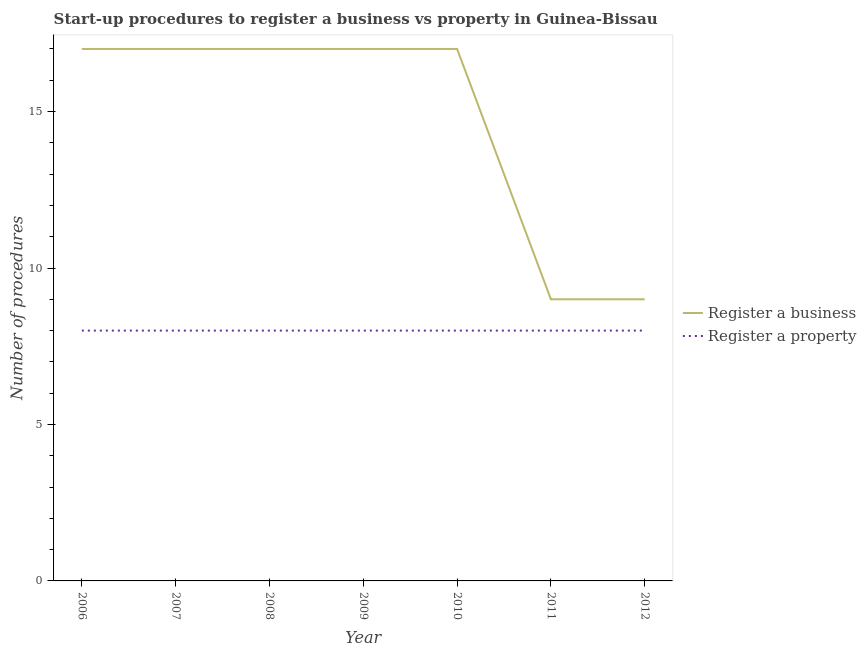How many different coloured lines are there?
Keep it short and to the point. 2. Does the line corresponding to number of procedures to register a business intersect with the line corresponding to number of procedures to register a property?
Provide a short and direct response. No. Is the number of lines equal to the number of legend labels?
Your response must be concise. Yes. What is the number of procedures to register a property in 2011?
Give a very brief answer. 8. Across all years, what is the maximum number of procedures to register a property?
Give a very brief answer. 8. Across all years, what is the minimum number of procedures to register a business?
Your answer should be compact. 9. In which year was the number of procedures to register a business maximum?
Keep it short and to the point. 2006. In which year was the number of procedures to register a business minimum?
Offer a terse response. 2011. What is the total number of procedures to register a business in the graph?
Offer a terse response. 103. What is the difference between the number of procedures to register a property in 2011 and the number of procedures to register a business in 2007?
Provide a short and direct response. -9. What is the average number of procedures to register a business per year?
Keep it short and to the point. 14.71. In the year 2007, what is the difference between the number of procedures to register a property and number of procedures to register a business?
Your answer should be very brief. -9. What is the ratio of the number of procedures to register a property in 2008 to that in 2011?
Your answer should be very brief. 1. Is the number of procedures to register a business in 2011 less than that in 2012?
Offer a terse response. No. Is the difference between the number of procedures to register a business in 2008 and 2012 greater than the difference between the number of procedures to register a property in 2008 and 2012?
Ensure brevity in your answer.  Yes. What is the difference between the highest and the second highest number of procedures to register a business?
Your answer should be very brief. 0. What is the difference between the highest and the lowest number of procedures to register a business?
Your answer should be very brief. 8. In how many years, is the number of procedures to register a property greater than the average number of procedures to register a property taken over all years?
Make the answer very short. 0. Is the sum of the number of procedures to register a business in 2006 and 2011 greater than the maximum number of procedures to register a property across all years?
Your answer should be very brief. Yes. Is the number of procedures to register a business strictly less than the number of procedures to register a property over the years?
Ensure brevity in your answer.  No. What is the difference between two consecutive major ticks on the Y-axis?
Offer a very short reply. 5. Are the values on the major ticks of Y-axis written in scientific E-notation?
Provide a short and direct response. No. Where does the legend appear in the graph?
Provide a succinct answer. Center right. What is the title of the graph?
Offer a terse response. Start-up procedures to register a business vs property in Guinea-Bissau. Does "Primary school" appear as one of the legend labels in the graph?
Provide a short and direct response. No. What is the label or title of the Y-axis?
Keep it short and to the point. Number of procedures. What is the Number of procedures in Register a property in 2006?
Provide a succinct answer. 8. What is the Number of procedures in Register a property in 2009?
Your answer should be very brief. 8. What is the Number of procedures in Register a business in 2010?
Make the answer very short. 17. What is the Number of procedures of Register a property in 2010?
Provide a short and direct response. 8. What is the Number of procedures of Register a business in 2011?
Provide a short and direct response. 9. What is the Number of procedures in Register a property in 2012?
Offer a very short reply. 8. Across all years, what is the minimum Number of procedures of Register a business?
Offer a terse response. 9. What is the total Number of procedures of Register a business in the graph?
Offer a terse response. 103. What is the difference between the Number of procedures of Register a business in 2006 and that in 2007?
Provide a succinct answer. 0. What is the difference between the Number of procedures of Register a property in 2006 and that in 2007?
Give a very brief answer. 0. What is the difference between the Number of procedures of Register a property in 2006 and that in 2009?
Give a very brief answer. 0. What is the difference between the Number of procedures of Register a business in 2006 and that in 2010?
Provide a succinct answer. 0. What is the difference between the Number of procedures of Register a business in 2006 and that in 2011?
Your answer should be very brief. 8. What is the difference between the Number of procedures of Register a property in 2006 and that in 2012?
Your response must be concise. 0. What is the difference between the Number of procedures of Register a business in 2007 and that in 2008?
Provide a succinct answer. 0. What is the difference between the Number of procedures in Register a property in 2007 and that in 2008?
Offer a terse response. 0. What is the difference between the Number of procedures in Register a business in 2007 and that in 2010?
Ensure brevity in your answer.  0. What is the difference between the Number of procedures of Register a business in 2007 and that in 2012?
Your answer should be compact. 8. What is the difference between the Number of procedures in Register a property in 2007 and that in 2012?
Your answer should be very brief. 0. What is the difference between the Number of procedures in Register a property in 2008 and that in 2009?
Your answer should be compact. 0. What is the difference between the Number of procedures of Register a business in 2008 and that in 2010?
Give a very brief answer. 0. What is the difference between the Number of procedures in Register a property in 2008 and that in 2011?
Provide a short and direct response. 0. What is the difference between the Number of procedures in Register a business in 2008 and that in 2012?
Ensure brevity in your answer.  8. What is the difference between the Number of procedures of Register a property in 2008 and that in 2012?
Your response must be concise. 0. What is the difference between the Number of procedures of Register a business in 2009 and that in 2010?
Keep it short and to the point. 0. What is the difference between the Number of procedures of Register a business in 2009 and that in 2011?
Keep it short and to the point. 8. What is the difference between the Number of procedures in Register a business in 2010 and that in 2012?
Your answer should be compact. 8. What is the difference between the Number of procedures of Register a business in 2011 and that in 2012?
Offer a terse response. 0. What is the difference between the Number of procedures in Register a business in 2006 and the Number of procedures in Register a property in 2007?
Ensure brevity in your answer.  9. What is the difference between the Number of procedures of Register a business in 2006 and the Number of procedures of Register a property in 2008?
Ensure brevity in your answer.  9. What is the difference between the Number of procedures in Register a business in 2006 and the Number of procedures in Register a property in 2009?
Your answer should be compact. 9. What is the difference between the Number of procedures of Register a business in 2007 and the Number of procedures of Register a property in 2008?
Ensure brevity in your answer.  9. What is the difference between the Number of procedures in Register a business in 2008 and the Number of procedures in Register a property in 2009?
Keep it short and to the point. 9. What is the difference between the Number of procedures of Register a business in 2008 and the Number of procedures of Register a property in 2010?
Keep it short and to the point. 9. What is the difference between the Number of procedures in Register a business in 2008 and the Number of procedures in Register a property in 2012?
Provide a succinct answer. 9. What is the difference between the Number of procedures in Register a business in 2009 and the Number of procedures in Register a property in 2010?
Give a very brief answer. 9. What is the difference between the Number of procedures of Register a business in 2010 and the Number of procedures of Register a property in 2011?
Your answer should be very brief. 9. What is the difference between the Number of procedures in Register a business in 2011 and the Number of procedures in Register a property in 2012?
Offer a terse response. 1. What is the average Number of procedures in Register a business per year?
Your answer should be compact. 14.71. What is the average Number of procedures in Register a property per year?
Make the answer very short. 8. In the year 2007, what is the difference between the Number of procedures in Register a business and Number of procedures in Register a property?
Keep it short and to the point. 9. In the year 2008, what is the difference between the Number of procedures of Register a business and Number of procedures of Register a property?
Your response must be concise. 9. In the year 2009, what is the difference between the Number of procedures of Register a business and Number of procedures of Register a property?
Offer a very short reply. 9. In the year 2011, what is the difference between the Number of procedures in Register a business and Number of procedures in Register a property?
Offer a very short reply. 1. In the year 2012, what is the difference between the Number of procedures in Register a business and Number of procedures in Register a property?
Ensure brevity in your answer.  1. What is the ratio of the Number of procedures in Register a business in 2006 to that in 2007?
Your answer should be very brief. 1. What is the ratio of the Number of procedures of Register a property in 2006 to that in 2007?
Offer a terse response. 1. What is the ratio of the Number of procedures in Register a business in 2006 to that in 2008?
Make the answer very short. 1. What is the ratio of the Number of procedures of Register a property in 2006 to that in 2008?
Your answer should be very brief. 1. What is the ratio of the Number of procedures of Register a business in 2006 to that in 2009?
Keep it short and to the point. 1. What is the ratio of the Number of procedures in Register a property in 2006 to that in 2010?
Provide a succinct answer. 1. What is the ratio of the Number of procedures of Register a business in 2006 to that in 2011?
Your answer should be compact. 1.89. What is the ratio of the Number of procedures of Register a property in 2006 to that in 2011?
Your answer should be very brief. 1. What is the ratio of the Number of procedures of Register a business in 2006 to that in 2012?
Make the answer very short. 1.89. What is the ratio of the Number of procedures of Register a property in 2007 to that in 2008?
Make the answer very short. 1. What is the ratio of the Number of procedures of Register a property in 2007 to that in 2009?
Your answer should be very brief. 1. What is the ratio of the Number of procedures of Register a property in 2007 to that in 2010?
Offer a very short reply. 1. What is the ratio of the Number of procedures in Register a business in 2007 to that in 2011?
Your answer should be compact. 1.89. What is the ratio of the Number of procedures in Register a property in 2007 to that in 2011?
Offer a very short reply. 1. What is the ratio of the Number of procedures in Register a business in 2007 to that in 2012?
Your response must be concise. 1.89. What is the ratio of the Number of procedures of Register a business in 2008 to that in 2009?
Provide a short and direct response. 1. What is the ratio of the Number of procedures in Register a business in 2008 to that in 2010?
Your response must be concise. 1. What is the ratio of the Number of procedures in Register a business in 2008 to that in 2011?
Your response must be concise. 1.89. What is the ratio of the Number of procedures of Register a business in 2008 to that in 2012?
Offer a very short reply. 1.89. What is the ratio of the Number of procedures of Register a business in 2009 to that in 2010?
Keep it short and to the point. 1. What is the ratio of the Number of procedures of Register a property in 2009 to that in 2010?
Offer a very short reply. 1. What is the ratio of the Number of procedures of Register a business in 2009 to that in 2011?
Ensure brevity in your answer.  1.89. What is the ratio of the Number of procedures of Register a business in 2009 to that in 2012?
Provide a short and direct response. 1.89. What is the ratio of the Number of procedures of Register a business in 2010 to that in 2011?
Your answer should be compact. 1.89. What is the ratio of the Number of procedures of Register a property in 2010 to that in 2011?
Ensure brevity in your answer.  1. What is the ratio of the Number of procedures of Register a business in 2010 to that in 2012?
Offer a terse response. 1.89. What is the difference between the highest and the second highest Number of procedures in Register a property?
Ensure brevity in your answer.  0. 